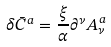Convert formula to latex. <formula><loc_0><loc_0><loc_500><loc_500>\delta \bar { C } ^ { a } = \frac { \xi } { \alpha } \partial ^ { \nu } A _ { \nu } ^ { a }</formula> 